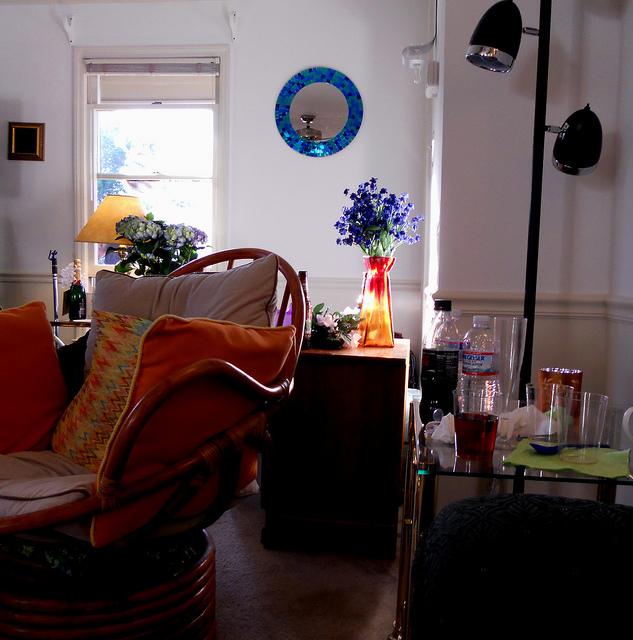What room is this picture?
Write a very short answer. Living room. What style of chair is pictured?
Quick response, please. Wicker. What drinks are on the table?
Give a very brief answer. Water. Is this room sunny and bright?
Keep it brief. Yes. 